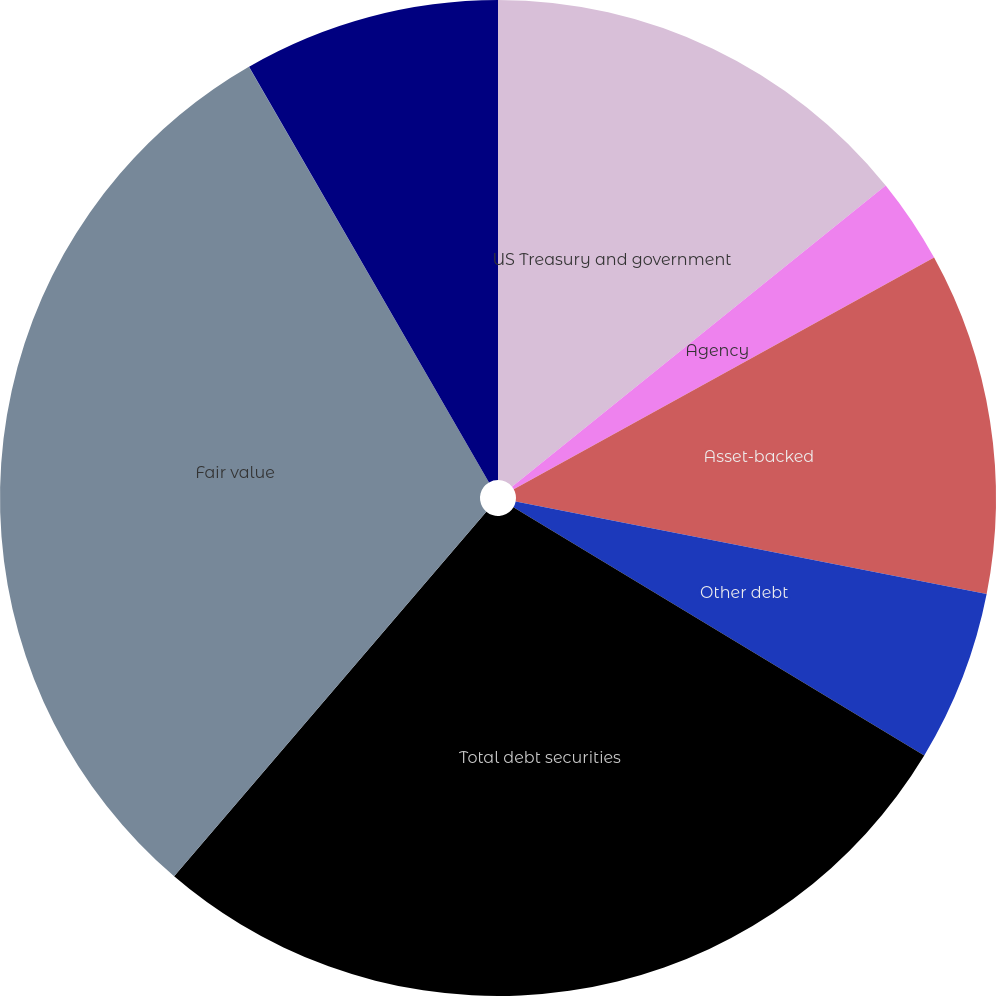<chart> <loc_0><loc_0><loc_500><loc_500><pie_chart><fcel>US Treasury and government<fcel>Agency<fcel>Asset-backed<fcel>Other debt<fcel>Total debt securities<fcel>Fair value<fcel>Weighted-average yield GAAP<fcel>Total debt securities held to<nl><fcel>14.2%<fcel>2.78%<fcel>11.11%<fcel>5.56%<fcel>27.62%<fcel>30.39%<fcel>0.01%<fcel>8.33%<nl></chart> 